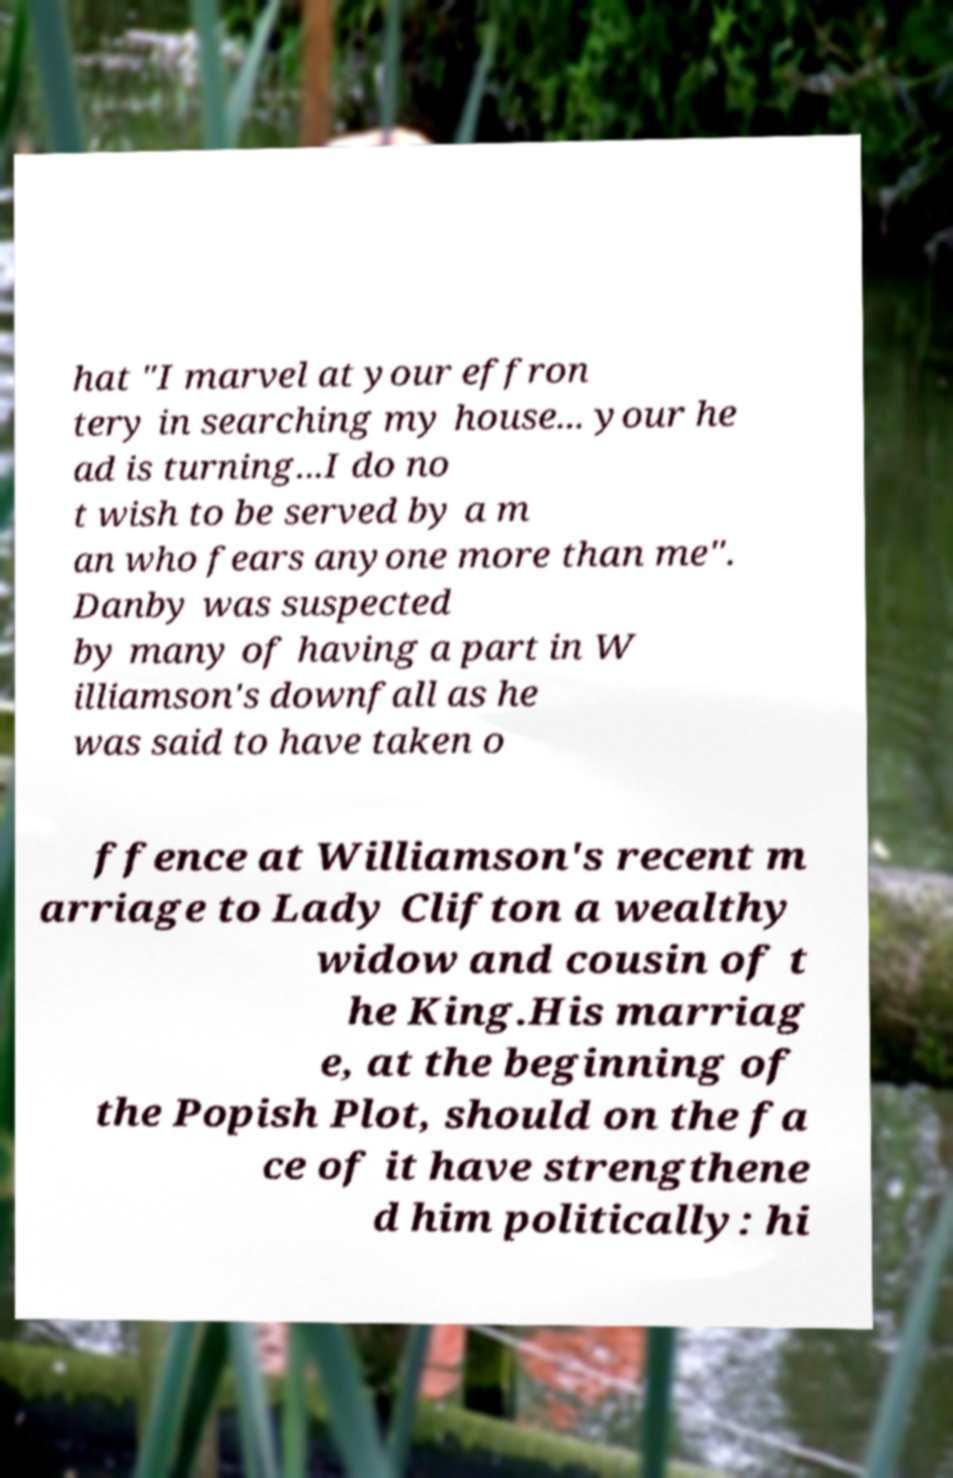Can you read and provide the text displayed in the image?This photo seems to have some interesting text. Can you extract and type it out for me? hat "I marvel at your effron tery in searching my house... your he ad is turning...I do no t wish to be served by a m an who fears anyone more than me". Danby was suspected by many of having a part in W illiamson's downfall as he was said to have taken o ffence at Williamson's recent m arriage to Lady Clifton a wealthy widow and cousin of t he King.His marriag e, at the beginning of the Popish Plot, should on the fa ce of it have strengthene d him politically: hi 